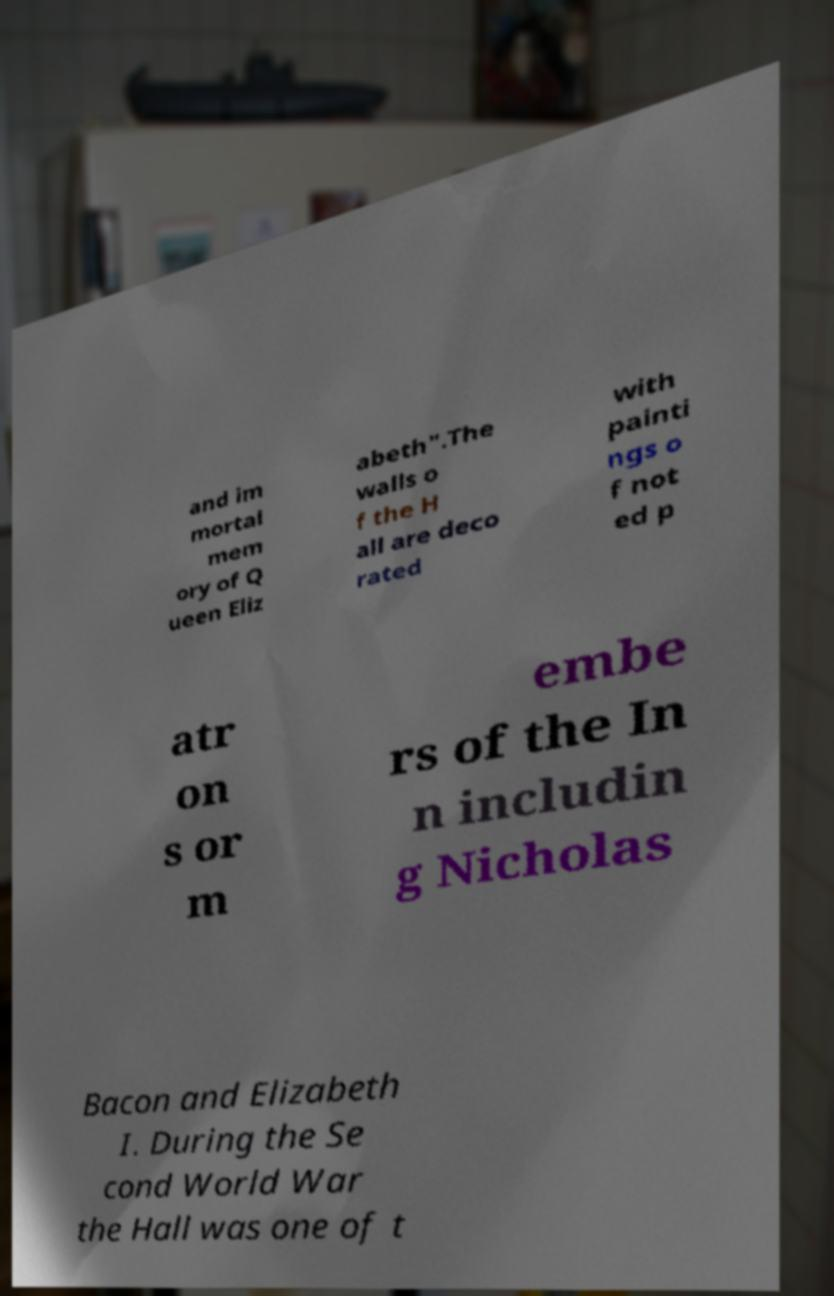Can you read and provide the text displayed in the image?This photo seems to have some interesting text. Can you extract and type it out for me? and im mortal mem ory of Q ueen Eliz abeth".The walls o f the H all are deco rated with painti ngs o f not ed p atr on s or m embe rs of the In n includin g Nicholas Bacon and Elizabeth I. During the Se cond World War the Hall was one of t 